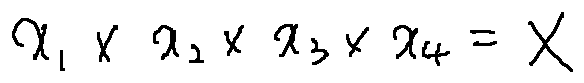<formula> <loc_0><loc_0><loc_500><loc_500>x _ { 1 } \times x _ { 2 } \times x _ { 3 } \times x _ { 4 } = X</formula> 